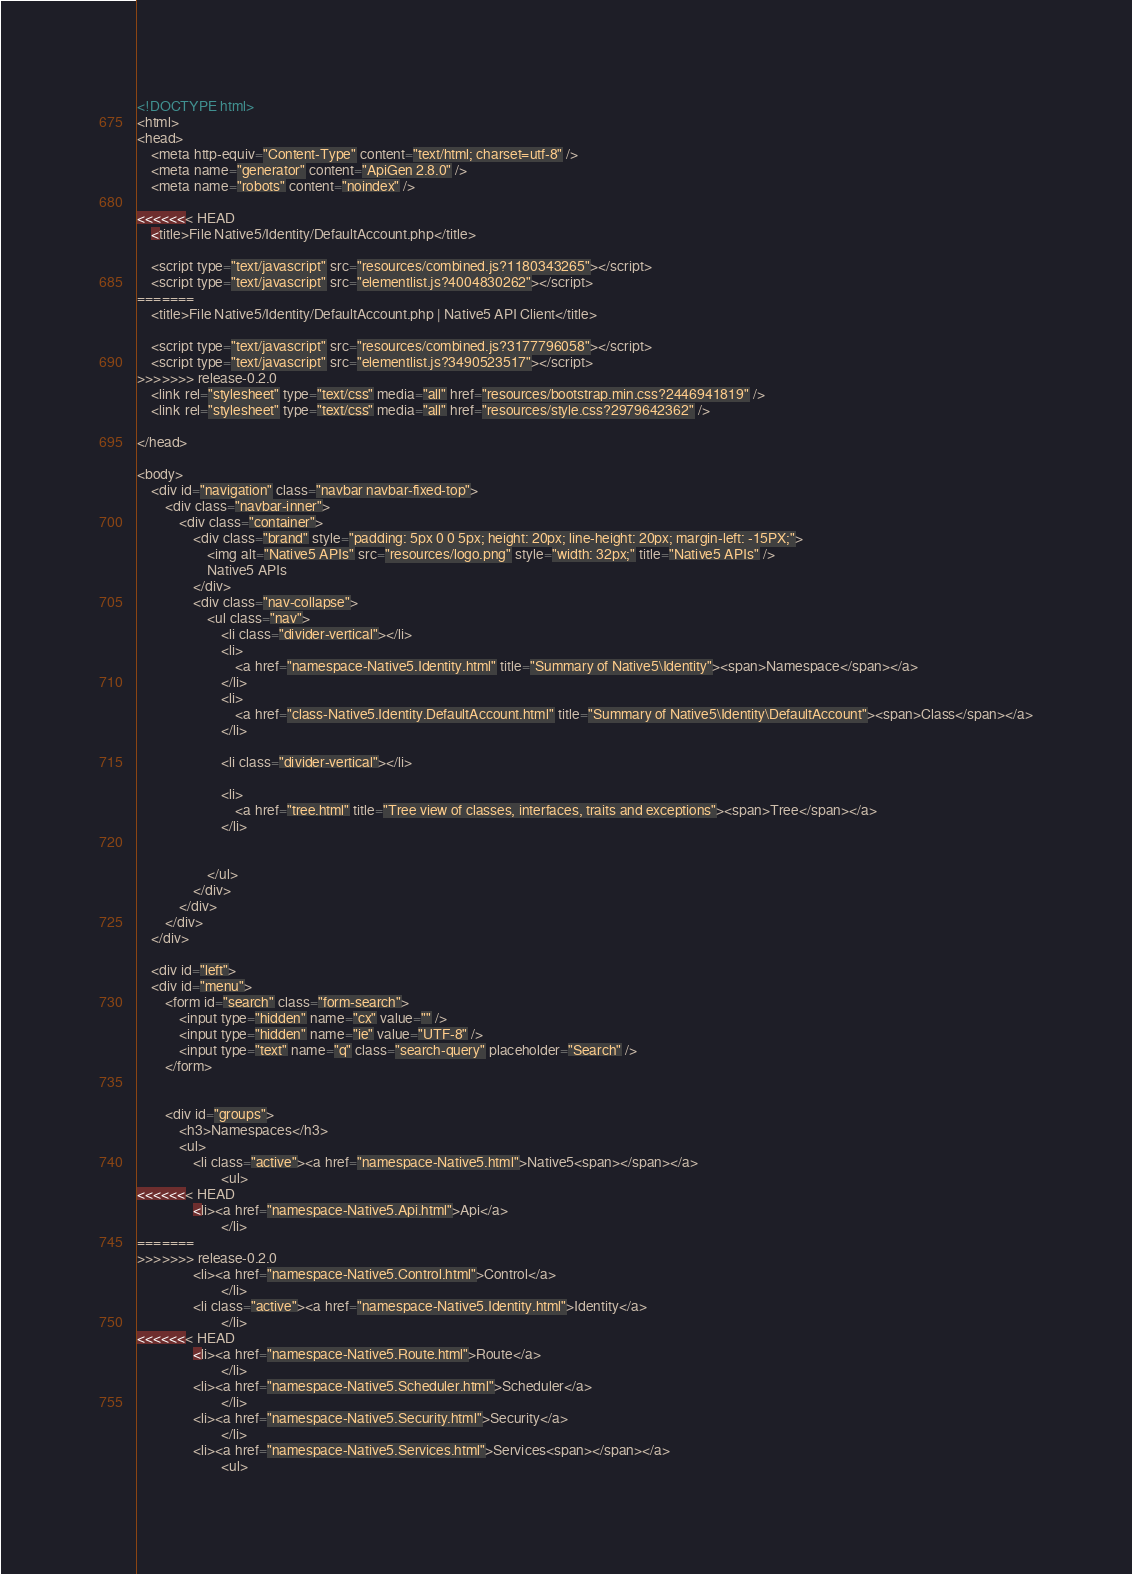<code> <loc_0><loc_0><loc_500><loc_500><_HTML_><!DOCTYPE html>
<html>
<head>
	<meta http-equiv="Content-Type" content="text/html; charset=utf-8" />
	<meta name="generator" content="ApiGen 2.8.0" />
	<meta name="robots" content="noindex" />

<<<<<<< HEAD
	<title>File Native5/Identity/DefaultAccount.php</title>

	<script type="text/javascript" src="resources/combined.js?1180343265"></script>
	<script type="text/javascript" src="elementlist.js?4004830262"></script>
=======
	<title>File Native5/Identity/DefaultAccount.php | Native5 API Client</title>

	<script type="text/javascript" src="resources/combined.js?3177796058"></script>
	<script type="text/javascript" src="elementlist.js?3490523517"></script>
>>>>>>> release-0.2.0
	<link rel="stylesheet" type="text/css" media="all" href="resources/bootstrap.min.css?2446941819" />
	<link rel="stylesheet" type="text/css" media="all" href="resources/style.css?2979642362" />

</head>

<body>
	<div id="navigation" class="navbar navbar-fixed-top">
		<div class="navbar-inner">
			<div class="container">
				<div class="brand" style="padding: 5px 0 0 5px; height: 20px; line-height: 20px; margin-left: -15PX;">
        			<img alt="Native5 APIs" src="resources/logo.png" style="width: 32px;" title="Native5 APIs" />
        			Native5 APIs
        		</div>
				<div class="nav-collapse">
					<ul class="nav">
        				<li class="divider-vertical"></li>
						<li>
							<a href="namespace-Native5.Identity.html" title="Summary of Native5\Identity"><span>Namespace</span></a>
						</li>
						<li>
							<a href="class-Native5.Identity.DefaultAccount.html" title="Summary of Native5\Identity\DefaultAccount"><span>Class</span></a>
						</li>

						<li class="divider-vertical"></li>

						<li>
							<a href="tree.html" title="Tree view of classes, interfaces, traits and exceptions"><span>Tree</span></a>
						</li>


					</ul>
				</div>
			</div>
		</div>
	</div>

	<div id="left">
	<div id="menu">
		<form id="search" class="form-search">
			<input type="hidden" name="cx" value="" />
			<input type="hidden" name="ie" value="UTF-8" />
			<input type="text" name="q" class="search-query" placeholder="Search" />
		</form>


		<div id="groups">
			<h3>Namespaces</h3>
			<ul>
				<li class="active"><a href="namespace-Native5.html">Native5<span></span></a>
						<ul>
<<<<<<< HEAD
				<li><a href="namespace-Native5.Api.html">Api</a>
						</li>
=======
>>>>>>> release-0.2.0
				<li><a href="namespace-Native5.Control.html">Control</a>
						</li>
				<li class="active"><a href="namespace-Native5.Identity.html">Identity</a>
						</li>
<<<<<<< HEAD
				<li><a href="namespace-Native5.Route.html">Route</a>
						</li>
				<li><a href="namespace-Native5.Scheduler.html">Scheduler</a>
						</li>
				<li><a href="namespace-Native5.Security.html">Security</a>
						</li>
				<li><a href="namespace-Native5.Services.html">Services<span></span></a>
						<ul></code> 